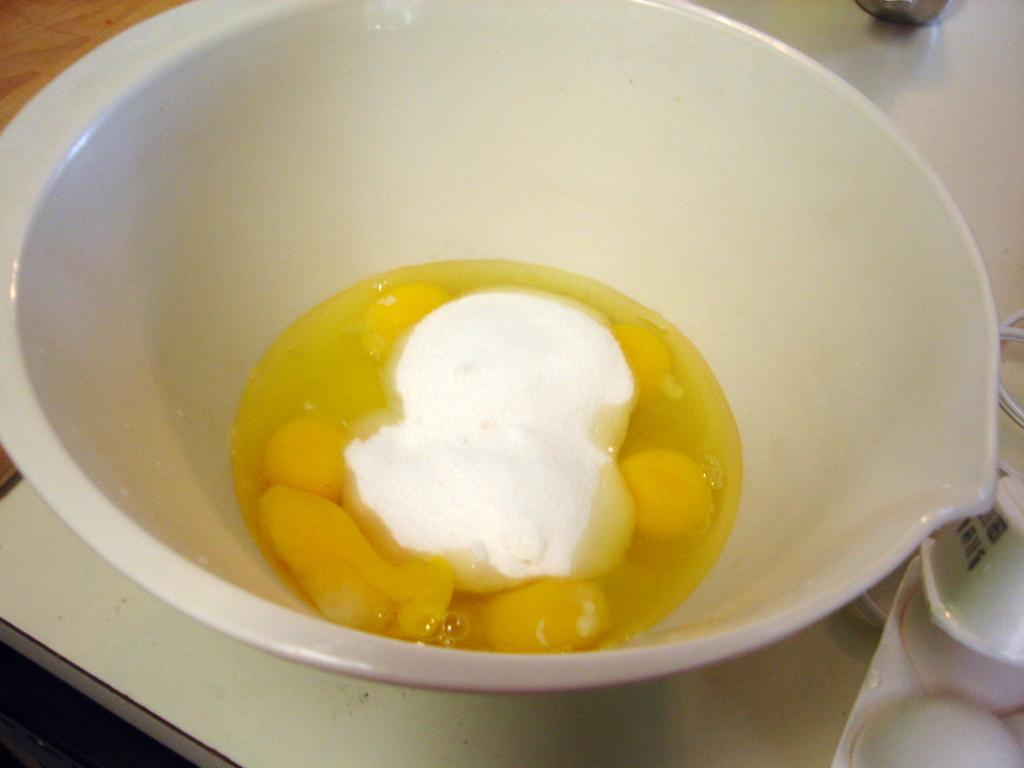What is in the bowl that is visible in the image? There is food in a bowl in the image. Where is the bowl located in the image? The bowl is placed on a table. What type of waste is visible in the middle of the image? There is no waste present in the image. Who is using the whip in the image? There is no whip or person using it in the image. 